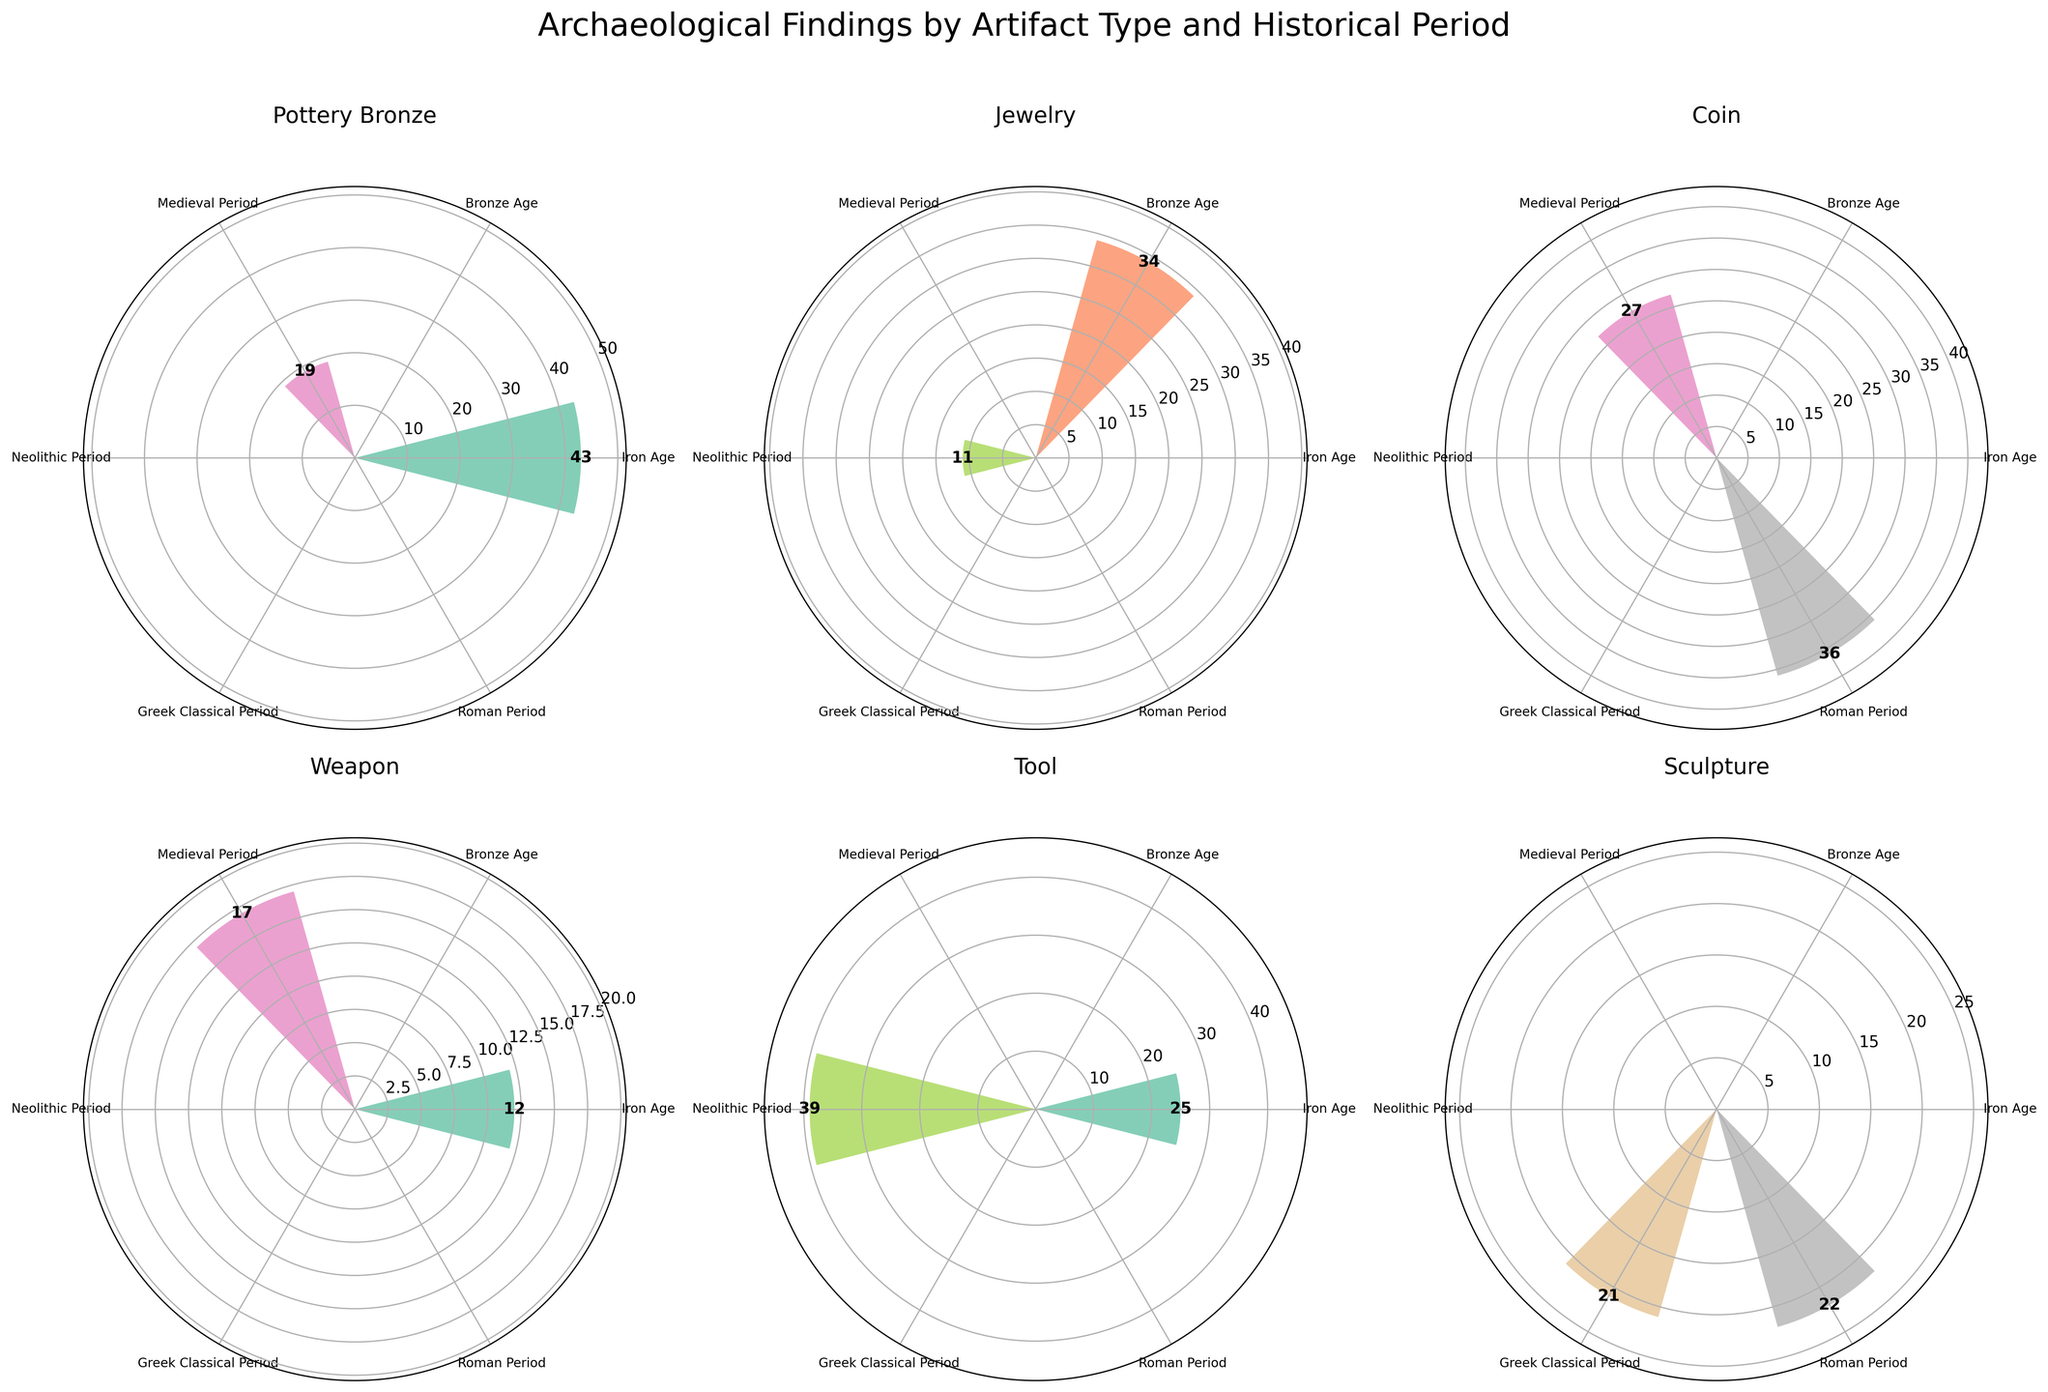What is the title of the figure? The title of the figure is located at the top center, which states the overall purpose of the visualization.
Answer: Archaeological Findings by Artifact Type and Historical Period How many different artifact types are displayed in the figure? By counting the number of distinct subplots with different titles, one for each artifact type.
Answer: 6 Which artifact type has the highest count during the Iron Age? Look at the subplot titled 'Iron Age' and identify the bar with the highest value.
Answer: Pottery Bronze What is the total count of Tools across all historical periods? Sum the counts of Tools in each historical period by referring to the corresponding position in the Tool subplot.
Answer: 64 (39 Neolithic + 25 Iron Age) Which historical period has the least count for Jewelry? Identify the smallest bar in the Jewels subplot and read the corresponding historical period.
Answer: Neolithic Period What is the average count of artifacts in the Roman Period across all types? Identify counts for all artifact types in the Roman Period and then average them by summing and dividing by the number of types.
Answer: 29 (36 Coin + 22 Sculpture)/2 Which historical period has the most diversity in artifact types? Count the number of different artifact types within each historical period by looking across the subplots for each period.
Answer: Iron Age Compare the counts of Pottery Bronze and Jewelry during the Bronze Age. Which is greater? Compare the bar heights for Pottery Bronze and Jewelry in the Bronze Age section of their respective subplots.
Answer: Pottery Bronze Which artifact type shows a consistent presence across multiple historical periods? By observing all the subplots and noting which artifact types appear in multiple historical periods.
Answer: Pottery Bronze Is the count of artifacts during the Medieval Period higher for Weapons or Coins? Compare the counts of artifacts in the Medieval Period between the Weapon subplot and the Coin subplot.
Answer: Coin 